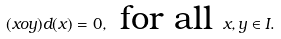<formula> <loc_0><loc_0><loc_500><loc_500>( x o y ) d ( x ) = 0 , \text { for all } x , y \in I .</formula> 